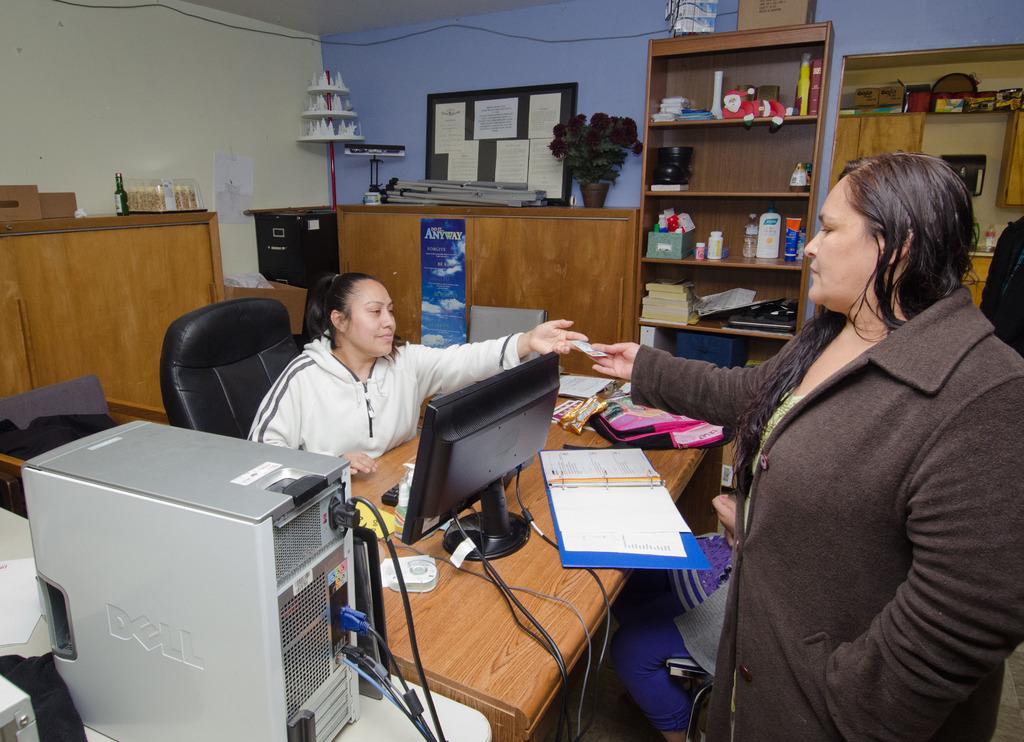Could you give a brief overview of what you see in this image? In this picture we can see a table and a woman is sitting on a chair. This is a monitor and its a cpu. At the right side of the picture we can see one woman standing and giving something to this woman. On the background of the picture we can see a wall, a cupboards. This is a bottle , flower vase. In this cupboard we can see few items arranged. 